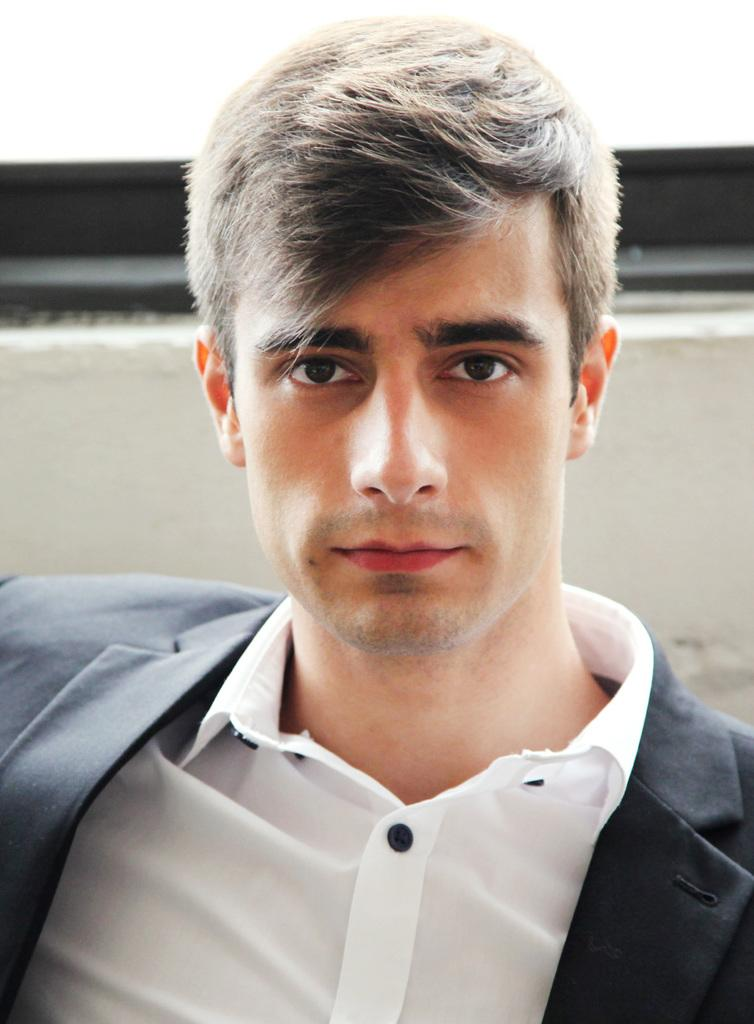What is the main subject in the foreground of the image? There is a man in the foreground of the image. What is the man wearing in the image? The man is wearing a coat in the image. What can be seen in the background of the image? There appears to be a wall in the background of the image. What type of wind can be seen blowing through the man's hair in the image? There is no wind present in the image, and the man's hair is not shown. What is the man's desire in the image? There is no indication of the man's desires in the image, as it only shows him wearing a coat and standing in front of a wall. 